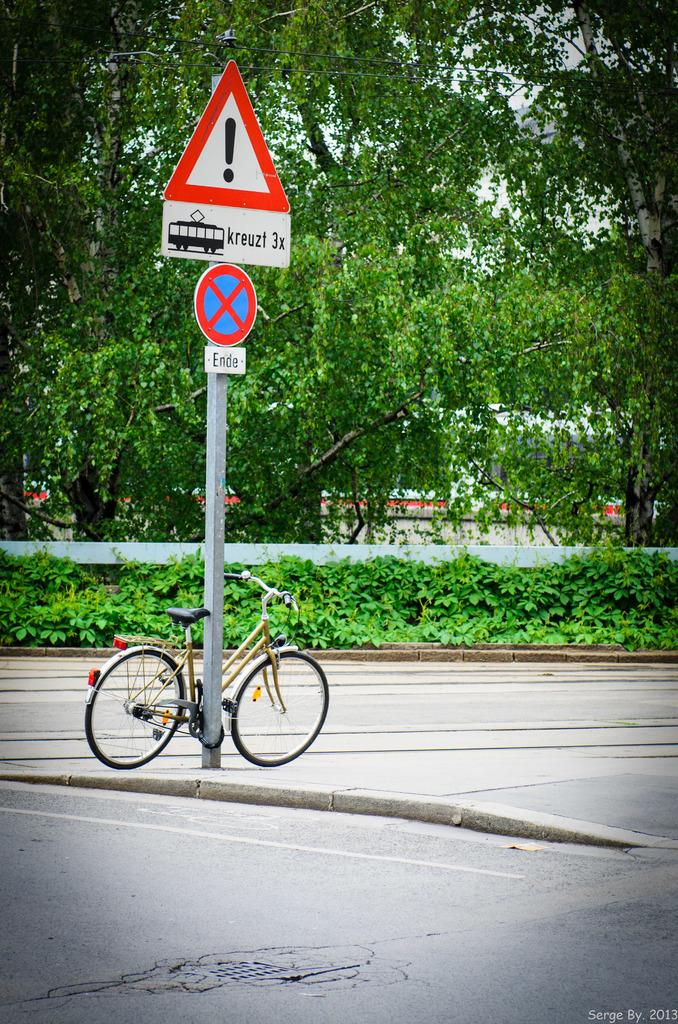<image>
Present a compact description of the photo's key features. At the side of the road a sign post that reads kreuzt 3x with a bicycle parked underneath it. 